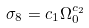<formula> <loc_0><loc_0><loc_500><loc_500>\sigma _ { 8 } = c _ { 1 } \Omega _ { 0 } ^ { c _ { 2 } }</formula> 